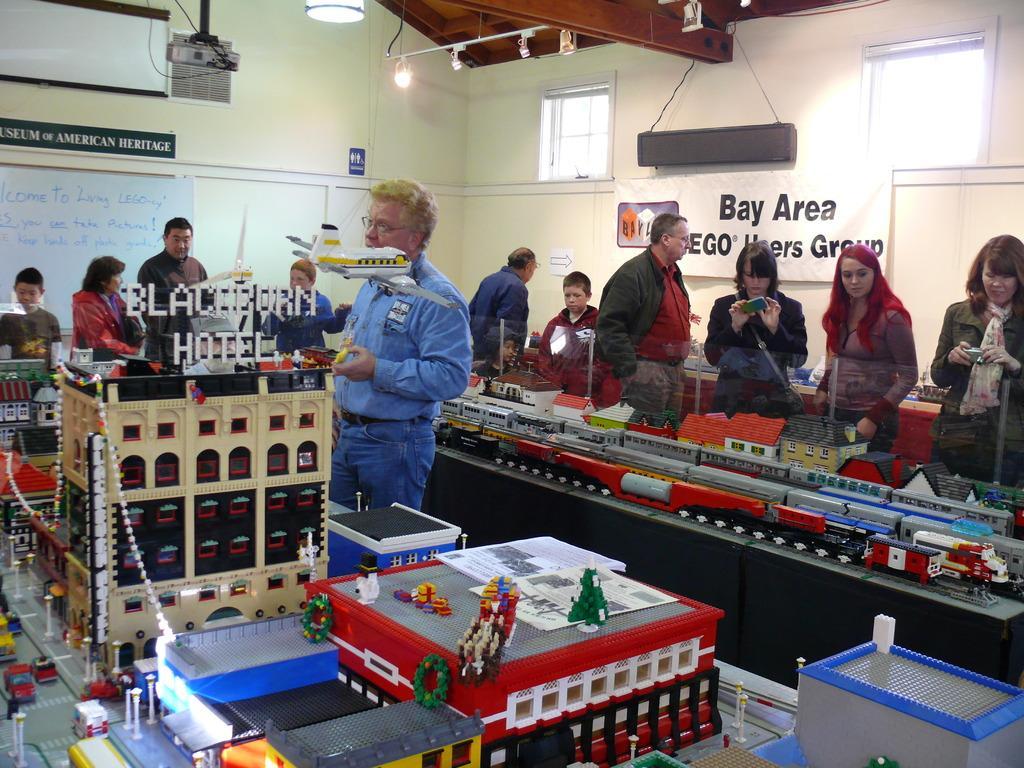Please provide a concise description of this image. There are people and we can see miniature on the table and airplane in the air. We can see glass. In the background we can see wall, boards, white banner, projector, windows, rod and lights. 